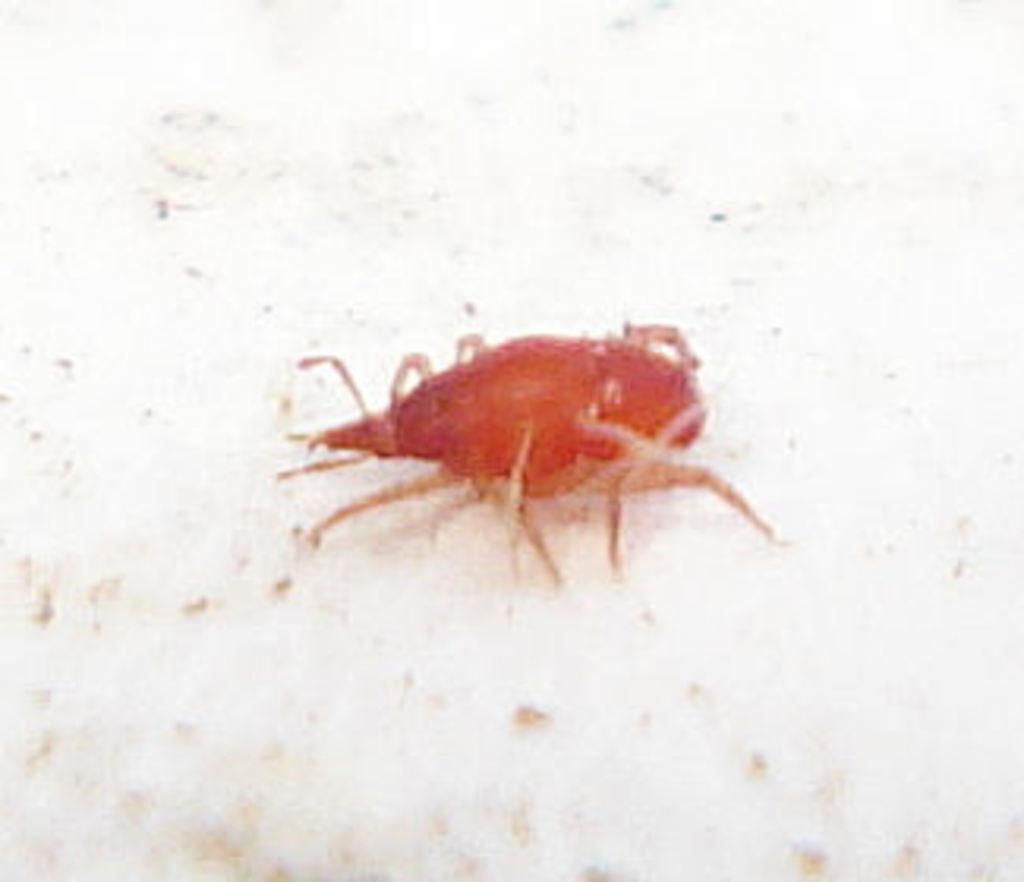What color is the insect in the image? The insect in the image is red. What is the insect doing in the image? The insect is crawling on a white surface. What type of glue is the insect using to stick to the white surface in the image? There is no indication in the image that the insect is using glue to stick to the white surface. 